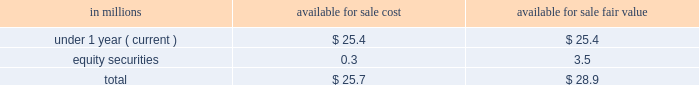Scheduled maturities of our marketable securities are as follows: .
As of may 27 , 2018 , we did not any have cash and cash equivalents pledged as collateral for derivative contracts .
As of may 27 , 2018 , $ 0.9 million of certain accounts receivable were pledged as collateral against a foreign uncommitted line of credit .
The fair value and carrying amounts of long-term debt , including the current portion , were $ 14169.7 million and $ 14268.8 million , respectively , as of may 27 , 2018 .
The fair value of long-term debt was estimated using market quotations and discounted cash flows based on our current incremental borrowing rates for similar types of instruments .
Long-term debt is a level 2 liability in the fair value hierarchy .
Risk management activities as a part of our ongoing operations , we are exposed to market risks such as changes in interest and foreign currency exchange rates and commodity and equity prices .
To manage these risks , we may enter into various derivative transactions ( e.g. , futures , options , and swaps ) pursuant to our established policies .
Commodity price risk many commodities we use in the production and distribution of our products are exposed to market price risks .
We utilize derivatives to manage price risk for our principal ingredients and energy costs , including grains ( oats , wheat , and corn ) , oils ( principally soybean ) , dairy products , natural gas , and diesel fuel .
Our primary objective when entering into these derivative contracts is to achieve certainty with regard to the future price of commodities purchased for use in our supply chain .
We manage our exposures through a combination of purchase orders , long-term contracts with suppliers , exchange-traded futures and options , and over-the-counter options and swaps .
We offset our exposures based on current and projected market conditions and generally seek to acquire the inputs at as close to our planned cost as possible .
We use derivatives to manage our exposure to changes in commodity prices .
We do not perform the assessments required to achieve hedge accounting for commodity derivative positions .
Accordingly , the changes in the values of these derivatives are recorded currently in cost of sales in our consolidated statements of earnings .
Although we do not meet the criteria for cash flow hedge accounting , we believe that these instruments are effective in achieving our objective of providing certainty in the future price of commodities purchased for use in our supply chain .
Accordingly , for purposes of measuring segment operating performance these gains and losses are reported in unallocated corporate items outside of segment operating results until such time that the exposure we are managing affects earnings .
At that time we reclassify the gain or loss from unallocated corporate items to segment operating profit , allowing our operating segments to realize the economic effects of the derivative without experiencing any resulting mark-to-market volatility , which remains in unallocated corporate items. .
What is the difference between carrying amounts of long-term debt and fair value? 
Computations: (14268.8 - 14169.7)
Answer: 99.1. 